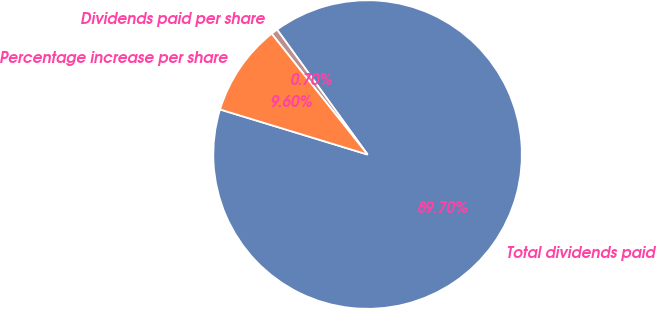<chart> <loc_0><loc_0><loc_500><loc_500><pie_chart><fcel>Total dividends paid<fcel>Dividends paid per share<fcel>Percentage increase per share<nl><fcel>89.7%<fcel>0.7%<fcel>9.6%<nl></chart> 